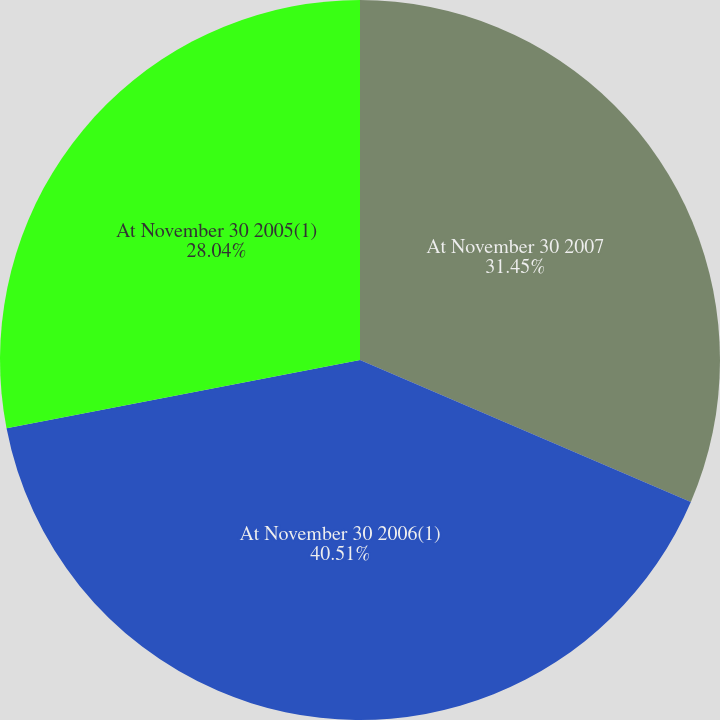Convert chart to OTSL. <chart><loc_0><loc_0><loc_500><loc_500><pie_chart><fcel>At November 30 2007<fcel>At November 30 2006(1)<fcel>At November 30 2005(1)<nl><fcel>31.45%<fcel>40.51%<fcel>28.04%<nl></chart> 